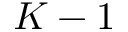<formula> <loc_0><loc_0><loc_500><loc_500>K - 1</formula> 